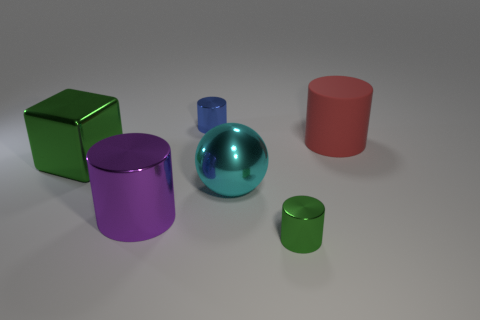Subtract all small green cylinders. How many cylinders are left? 3 Subtract 2 cylinders. How many cylinders are left? 2 Subtract all green cylinders. How many cylinders are left? 3 Add 1 big red objects. How many objects exist? 7 Subtract all red cylinders. Subtract all gray blocks. How many cylinders are left? 3 Subtract all spheres. How many objects are left? 5 Subtract all large cubes. Subtract all matte cylinders. How many objects are left? 4 Add 1 small shiny things. How many small shiny things are left? 3 Add 6 tiny things. How many tiny things exist? 8 Subtract 0 blue cubes. How many objects are left? 6 